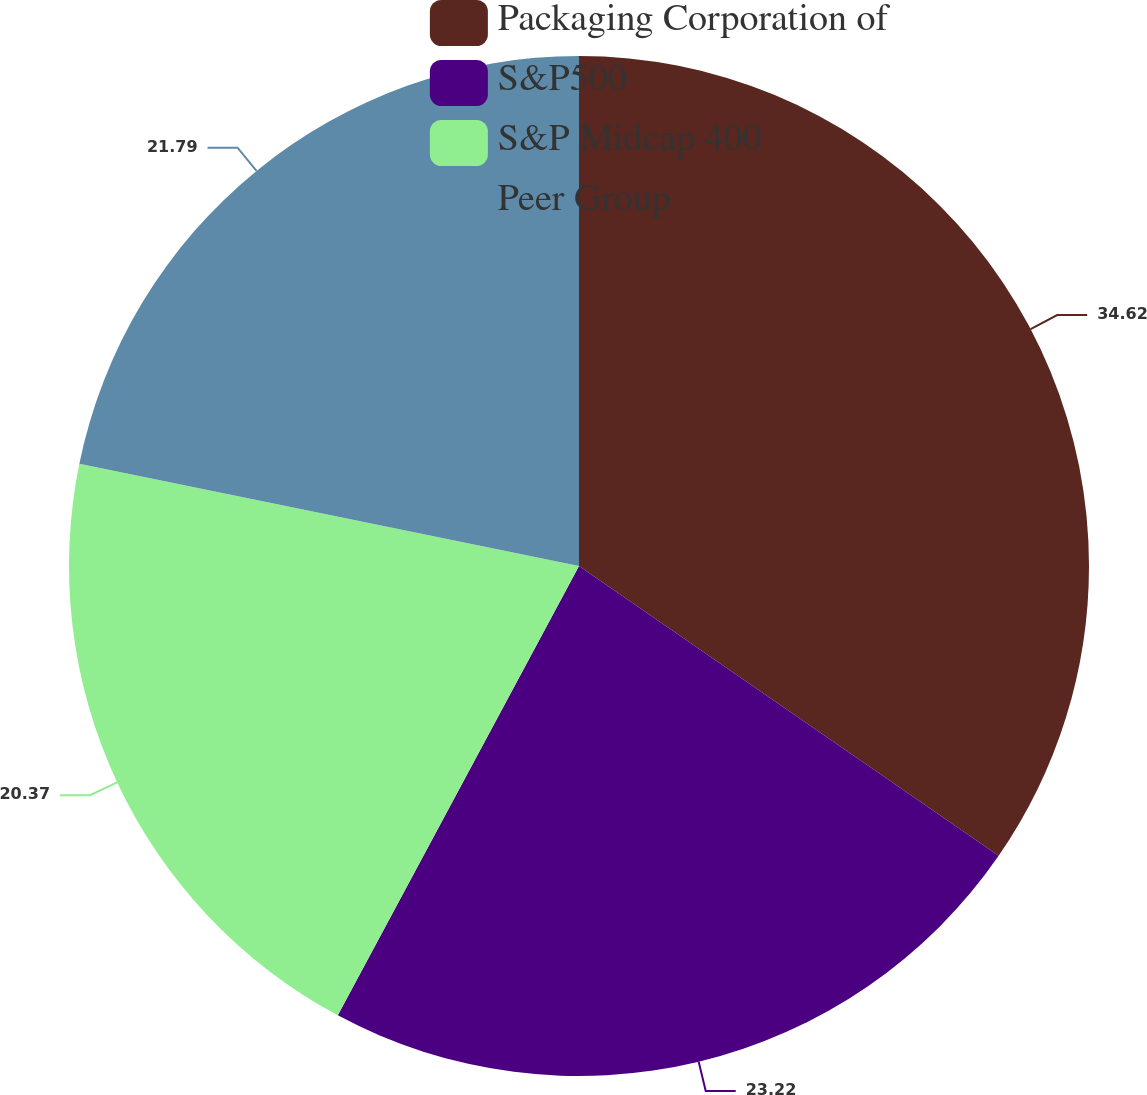Convert chart to OTSL. <chart><loc_0><loc_0><loc_500><loc_500><pie_chart><fcel>Packaging Corporation of<fcel>S&P500<fcel>S&P Midcap 400<fcel>Peer Group<nl><fcel>34.62%<fcel>23.22%<fcel>20.37%<fcel>21.79%<nl></chart> 